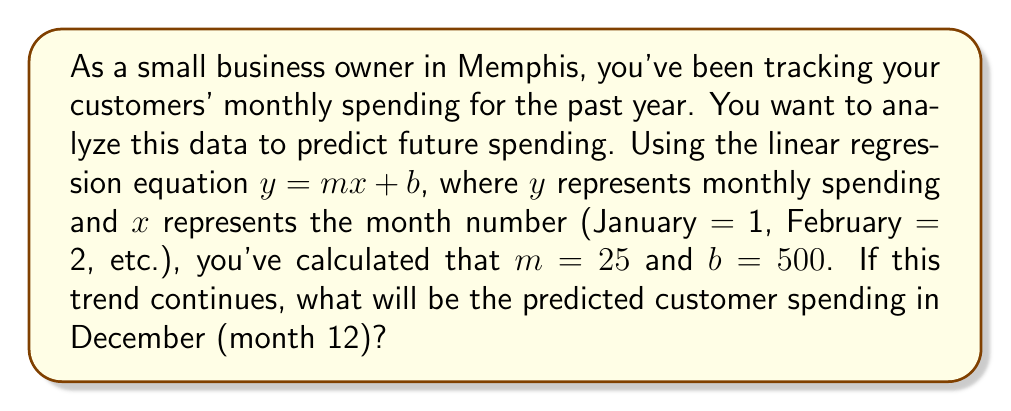Could you help me with this problem? Let's approach this step-by-step:

1. We're given the linear regression equation: $y = mx + b$
   Where:
   $y$ = monthly spending
   $x$ = month number
   $m$ = slope (rate of change in spending per month)
   $b$ = y-intercept (baseline spending)

2. We're told that $m = 25$ and $b = 500$

3. We want to predict spending for December, which is month 12

4. Let's substitute these values into our equation:
   $y = 25x + 500$

5. For December (month 12), $x = 12$

6. Now, let's calculate:
   $y = 25(12) + 500$
   $y = 300 + 500$
   $y = 800$

Therefore, the predicted customer spending for December is $800.
Answer: $800 